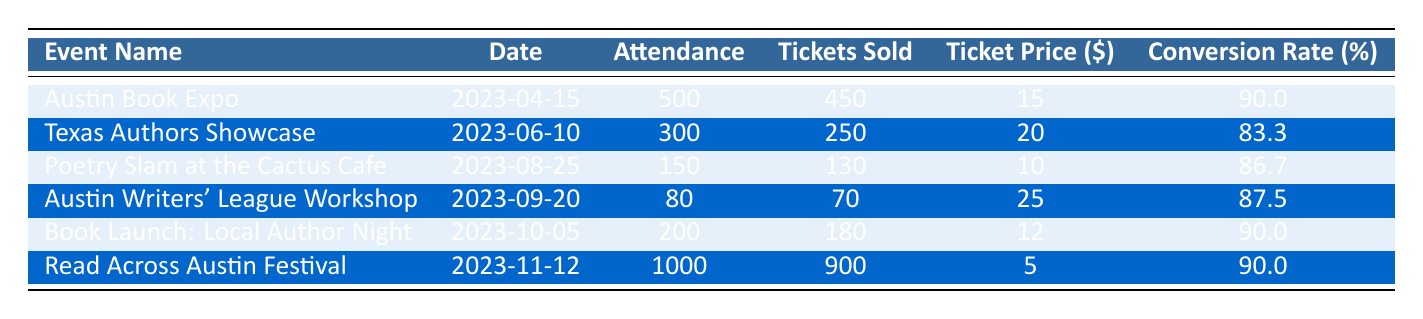What is the ticket price for the "Poetry Slam at the Cactus Cafe"? The ticket price column in the row corresponding to the "Poetry Slam at the Cactus Cafe" shows a value of 10.
Answer: 10 What was the attendance for the "Austin Book Expo"? The attendance column for the "Austin Book Expo" row provides a figure of 500.
Answer: 500 How many tickets were sold for the "Read Across Austin Festival"? From the "Read Across Austin Festival" row, the tickets sold are recorded as 900.
Answer: 900 What is the conversion rate for the "Texas Authors Showcase"? For the "Texas Authors Showcase," the conversion rate, as shown in the table, is 83.3%.
Answer: 83.3 What is the average ticket price of all events listed? The ticket prices are 15, 20, 10, 25, 12, and 5. Summing these gives 15 + 20 + 10 + 25 + 12 + 5 = 97. There are 6 events, so the average ticket price is 97/6 = approximately 16.17.
Answer: 16.17 Did the "Austin Writers' League Workshop" have more tickets sold than attendees? The workshop had 70 tickets sold and 80 attendees. Since 70 is less than 80, the answer is false.
Answer: No Which event had the highest attendance and what was the ticket price for that event? The "Read Across Austin Festival" had the highest attendance of 1000. The ticket price for that event is listed as 5.
Answer: 1000, 5 How does the conversion rate of "Book Launch: Local Author Night" compare to the average conversion rate of all events? The conversion rate for the "Book Launch: Local Author Night" is 90.0%. To find the average conversion rate, we calculate (90.0 + 83.3 + 86.7 + 87.5 + 90.0 + 90.0)/6 = 88.0%, so it is higher than average.
Answer: Higher How many total tickets were sold across all events? Adding the tickets sold (450 + 250 + 130 + 70 + 180 + 900) gives a total of 1980 tickets sold across all events.
Answer: 1980 